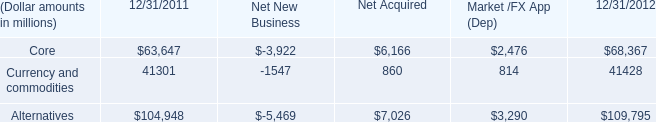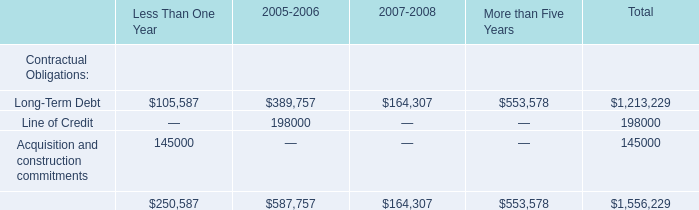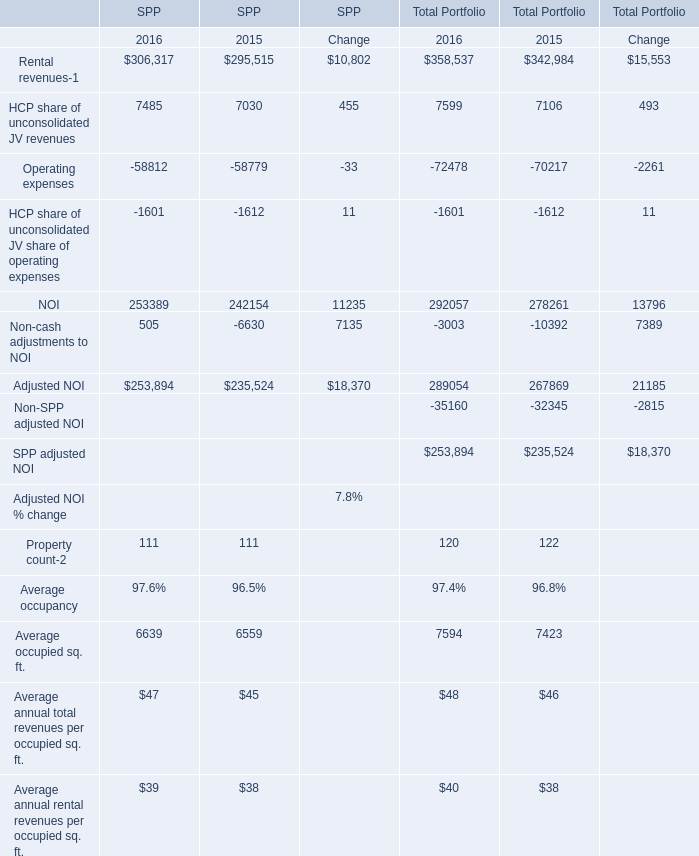what is the percentage change in the balance of currency and commodities from 2011 to 2012? 
Computations: ((41428 - 41301) / 41301)
Answer: 0.00307. 